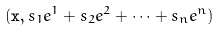Convert formula to latex. <formula><loc_0><loc_0><loc_500><loc_500>( \mathbf x , s _ { 1 } e ^ { 1 } + s _ { 2 } e ^ { 2 } + \dots + s _ { n } e ^ { n } )</formula> 